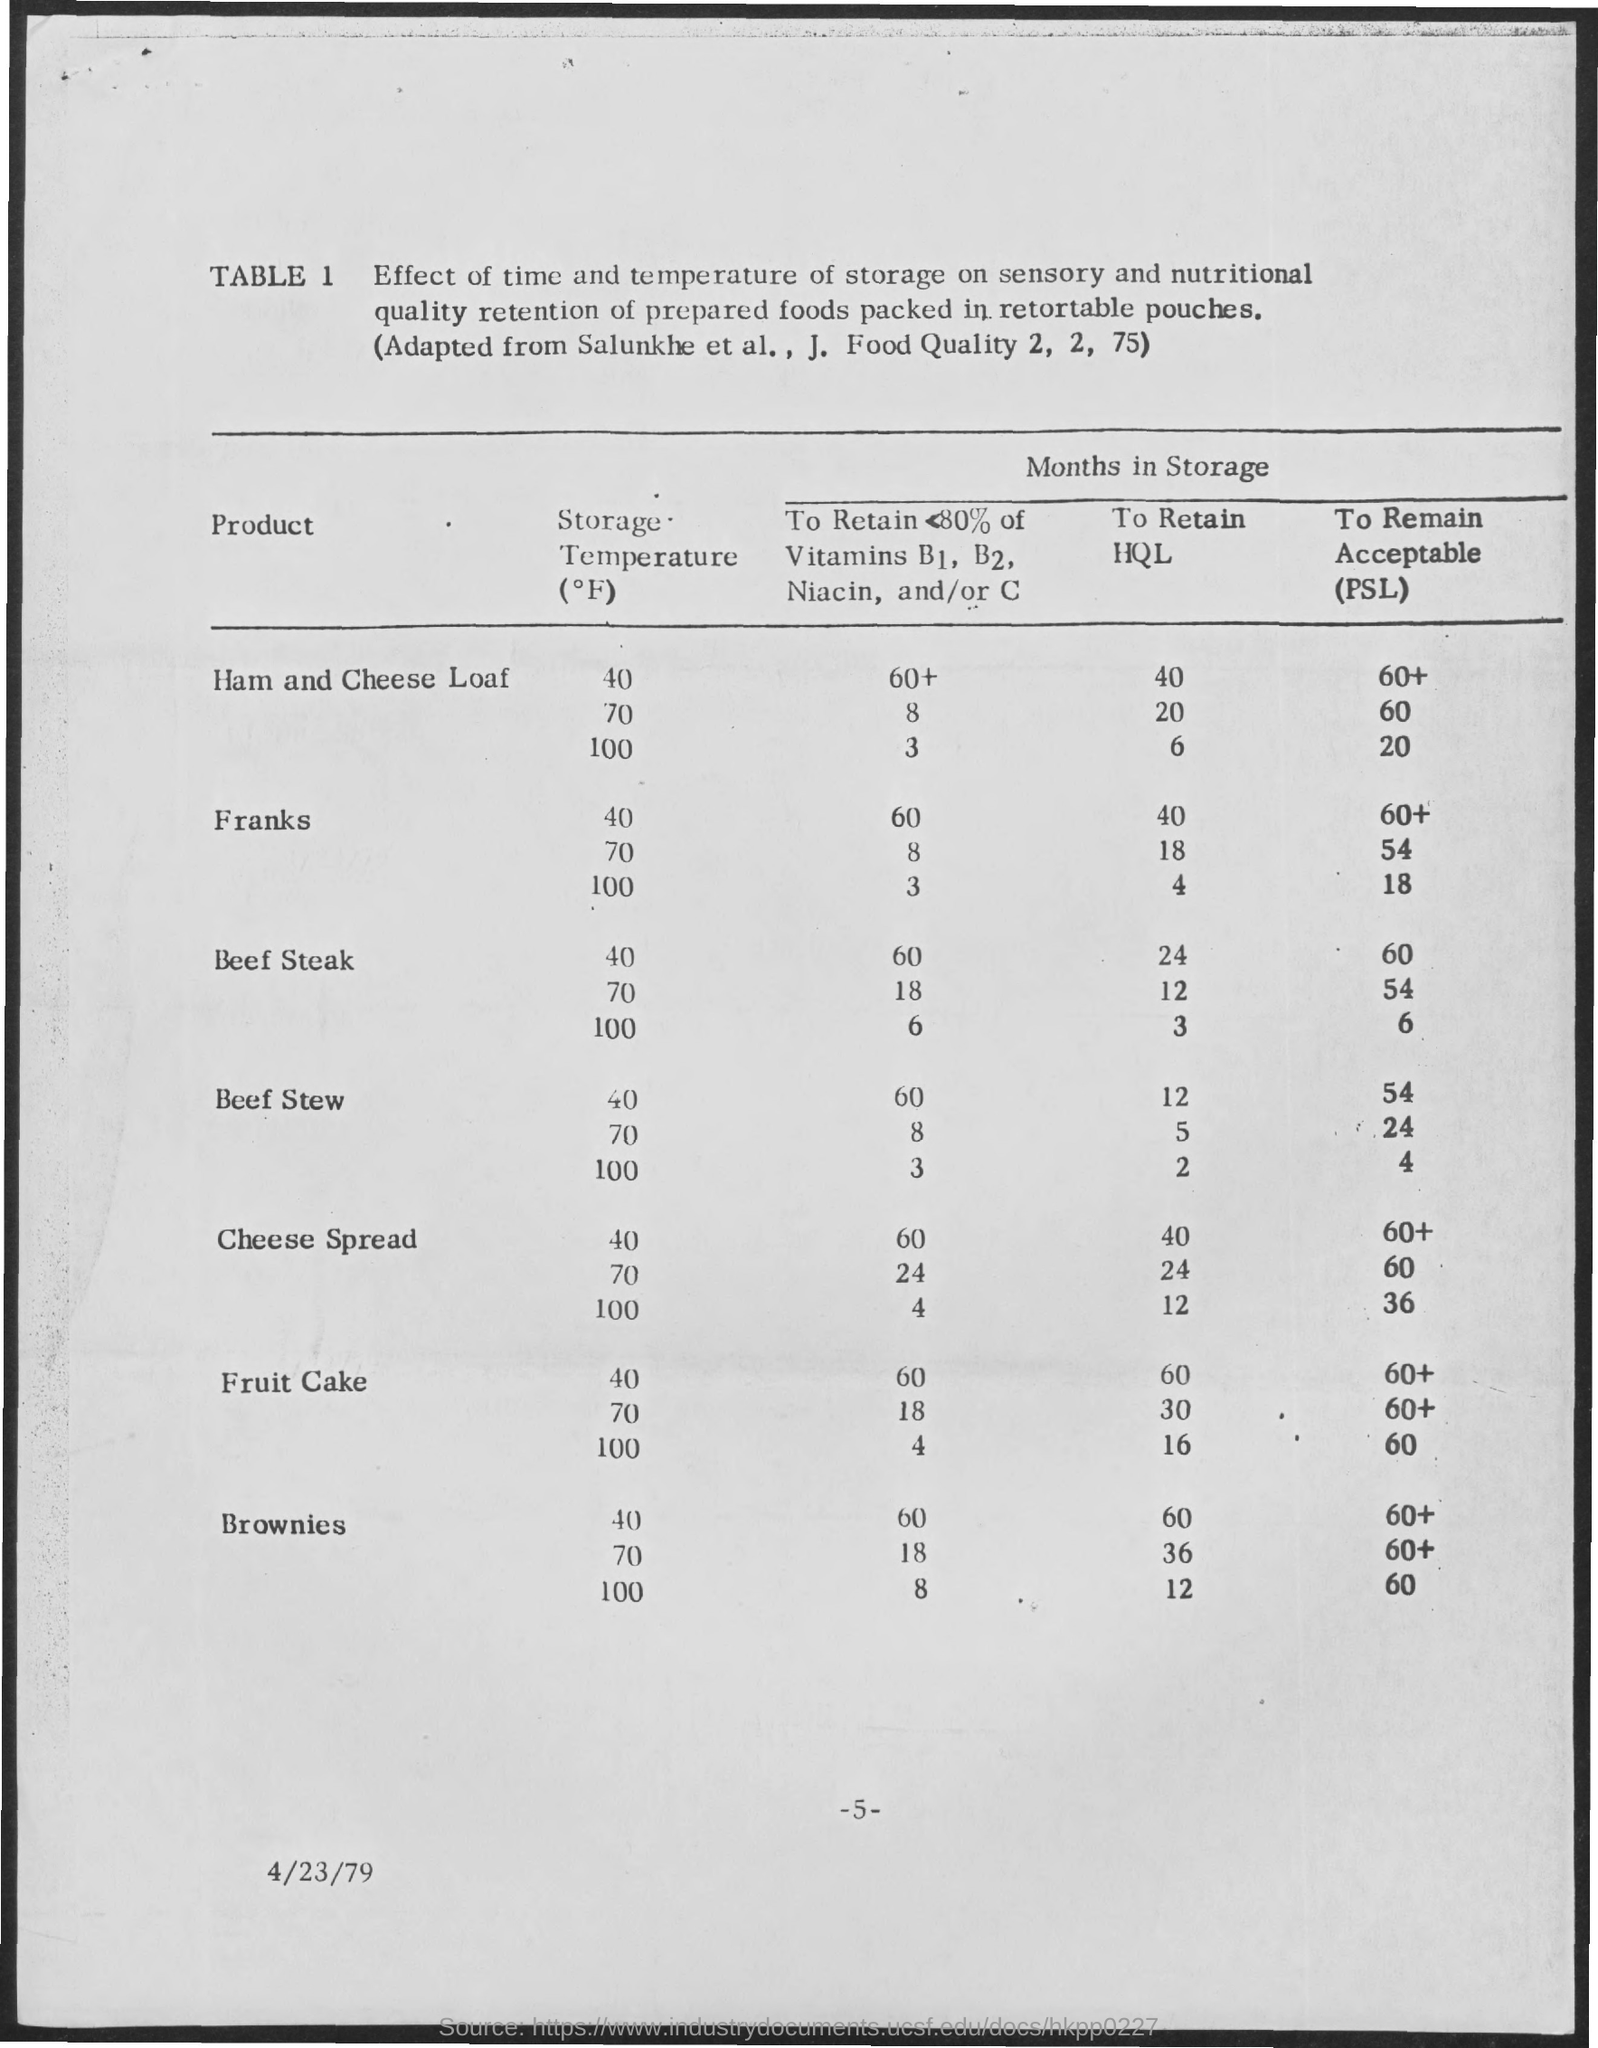Specify some key components in this picture. The document indicates that the date is April 23, 1979. 